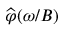Convert formula to latex. <formula><loc_0><loc_0><loc_500><loc_500>\widehat { \varphi } ( \omega / B )</formula> 